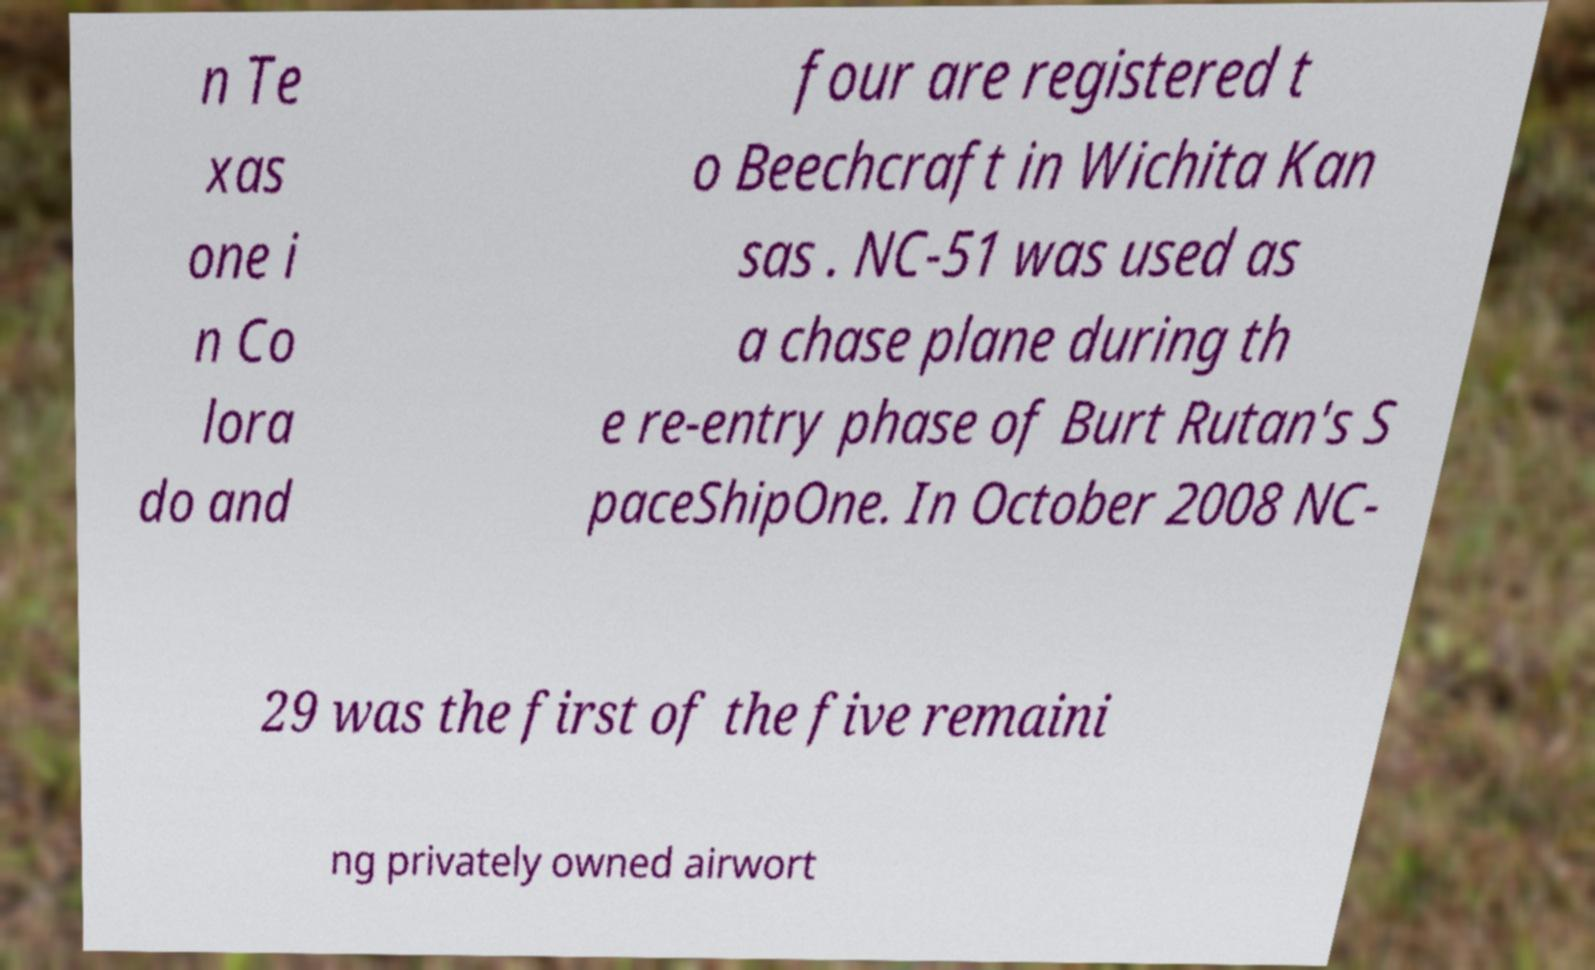Please read and relay the text visible in this image. What does it say? n Te xas one i n Co lora do and four are registered t o Beechcraft in Wichita Kan sas . NC-51 was used as a chase plane during th e re-entry phase of Burt Rutan's S paceShipOne. In October 2008 NC- 29 was the first of the five remaini ng privately owned airwort 